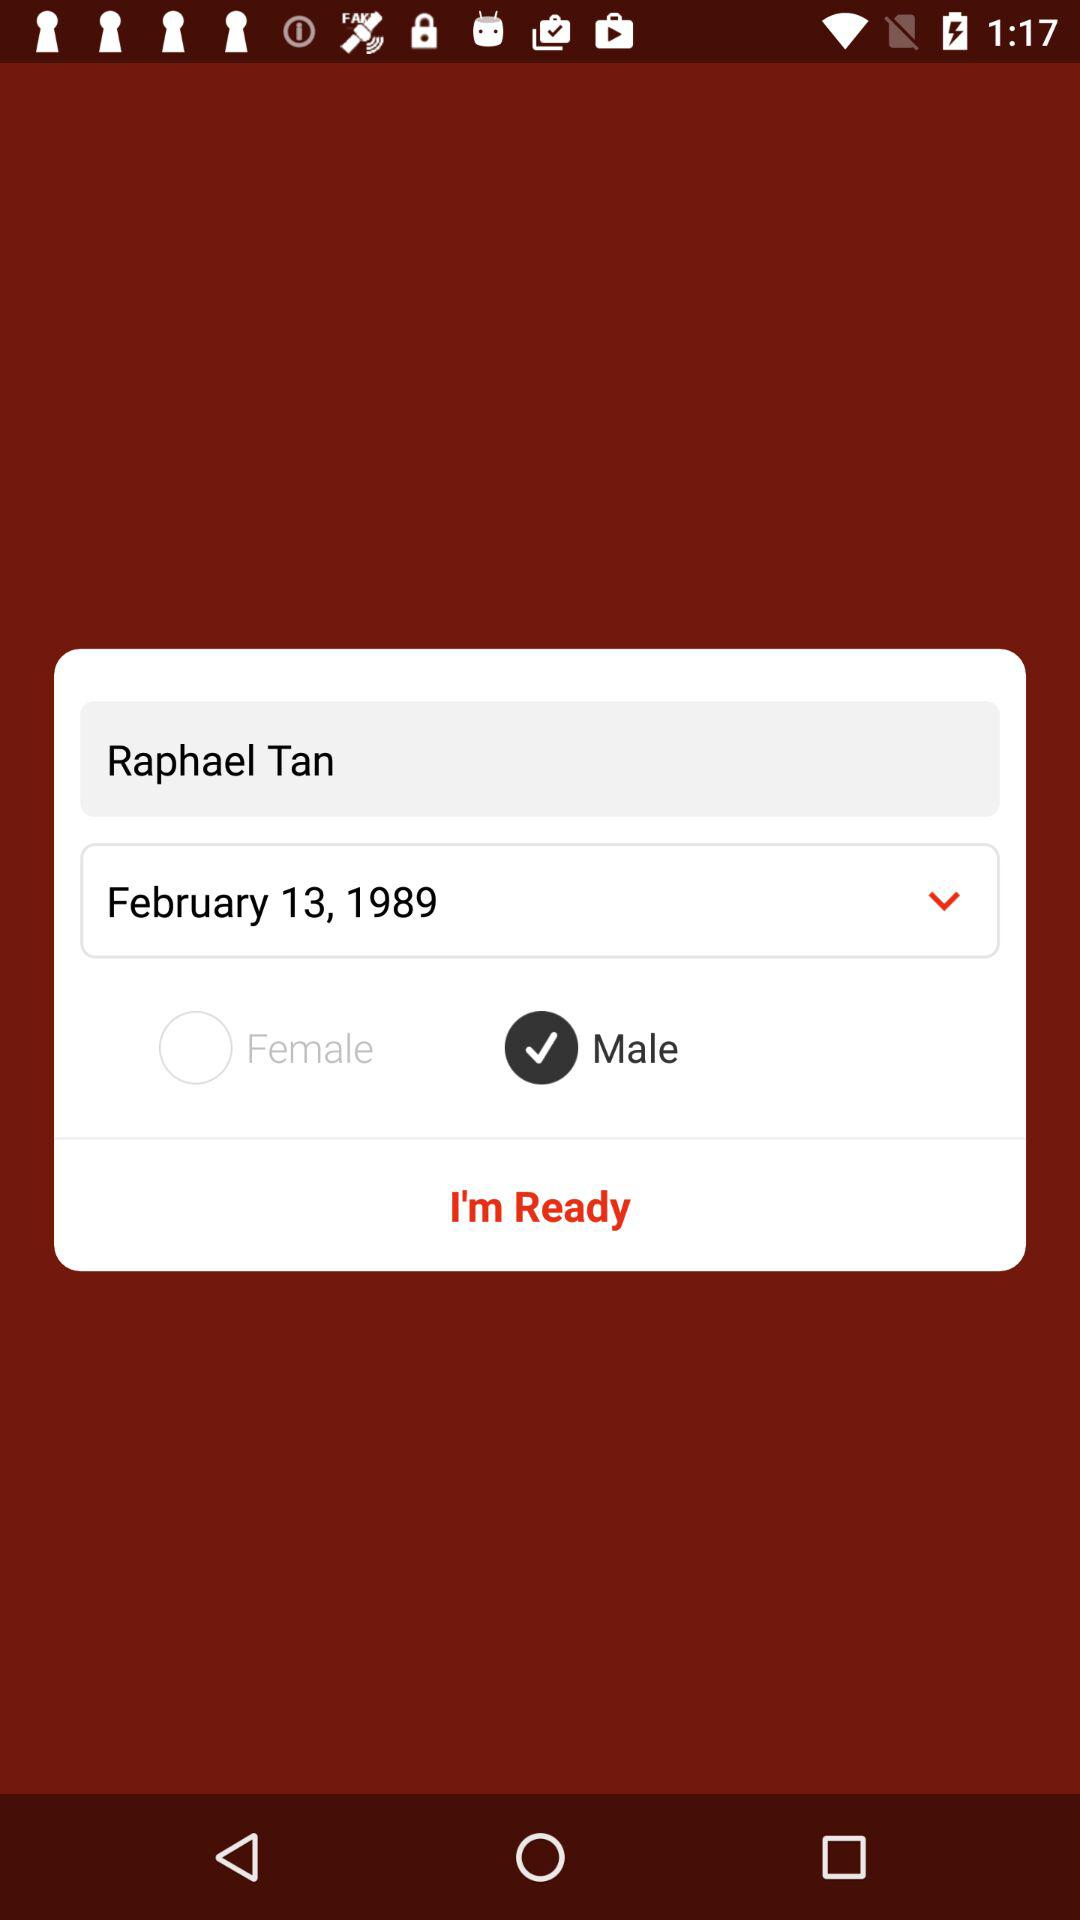What is the gender? The gender is male. 